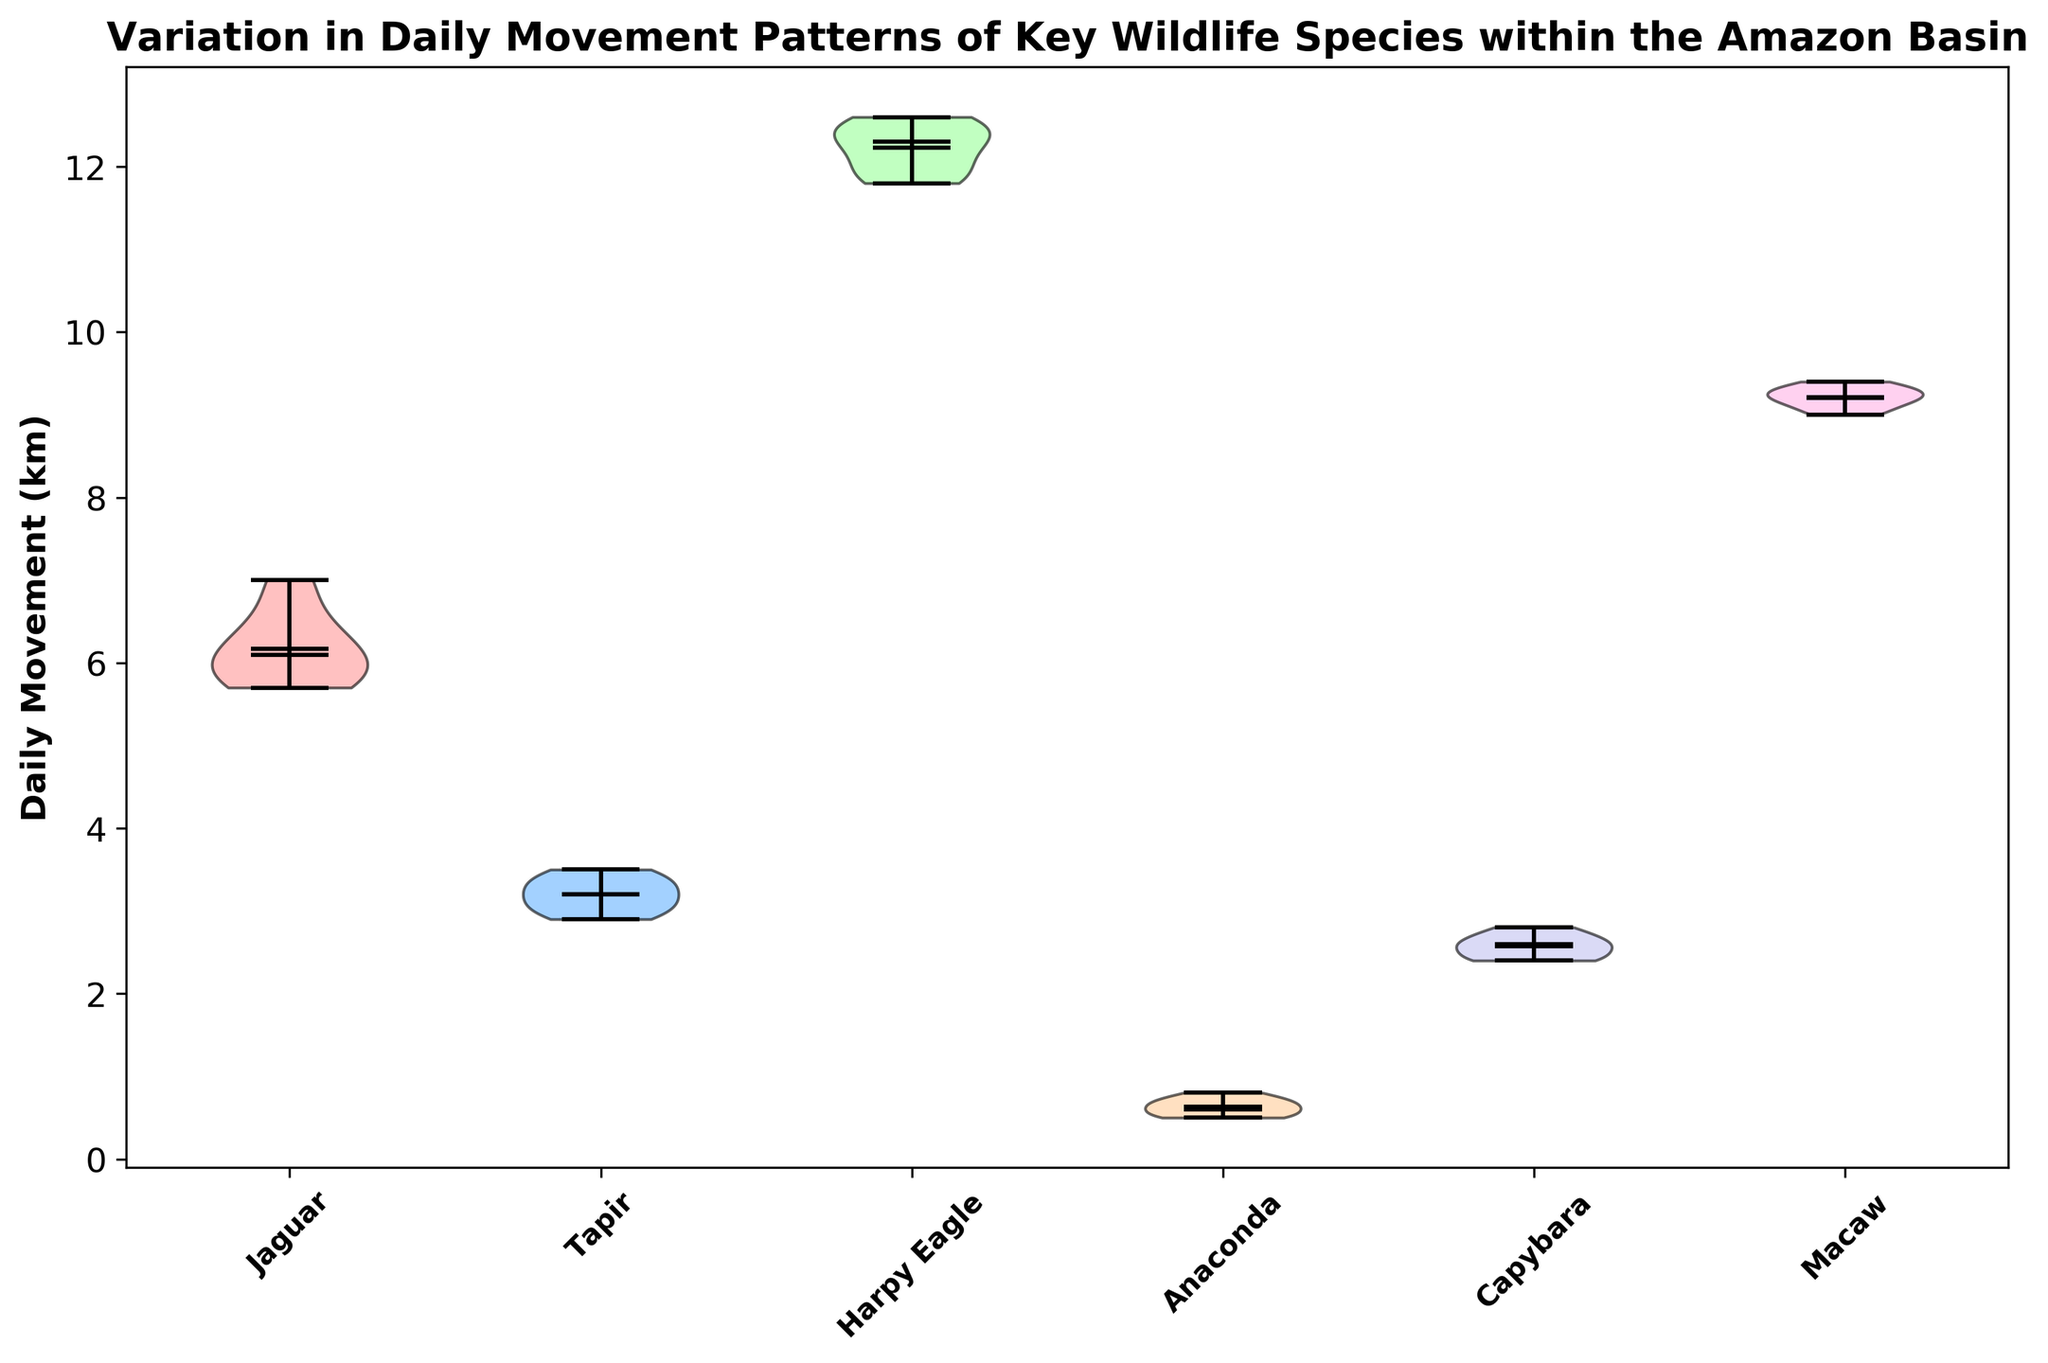What's the median daily movement of Jaguars? Look at the line within the Jaguar violin plot that represents the median daily movement distance.
Answer: 6.1 km Which species has the highest median daily movement? Compare the median lines of all species' violin plots to see which reaches the highest value.
Answer: Harpy Eagle What is the range of daily movement for Tapirs? The range is given by the distance between the minimum and maximum points in the Tapir’s violin plot.
Answer: 2.9 km to 3.5 km How does the median movement of Capybaras compare to Macaws? Compare the median lines within the Capybara and Macaw plots to determine if one is higher, lower, or equal.
Answer: Capybaras have a lower median daily movement than Macaws Which species shows the most variation in daily movement? The species with the widest violin plot indicates the greatest variation.
Answer: Harpy Eagle What is the average daily movement of Anacondas? Average the values given for Anacondas: (0.5 + 0.7 + 0.6 + 0.8 + 0.5 + 0.7 + 0.6) / 7
Answer: 0.63 km Does any species have a mean daily movement that is significantly different from its median? Look for species where the mean (usually marked by a dot) does not align closely with the median line in the violin plot.
Answer: No species shows a significant difference What is the interquartile range (IQR) for Jaguars? Visually assess the spread of the middle 50% (the thickest part) of the data in the Jaguar’s violin plot.
Answer: Approximately 5.8 km to 6.5 km Which species moves the least on average? Compare the average daily movement (represented by the dots) of all species to find the smallest.
Answer: Anaconda What color is used to represent Harpy Eagles in the plot? Identify the color used for the Harpy Eagle's violin plot.
Answer: Light blue 